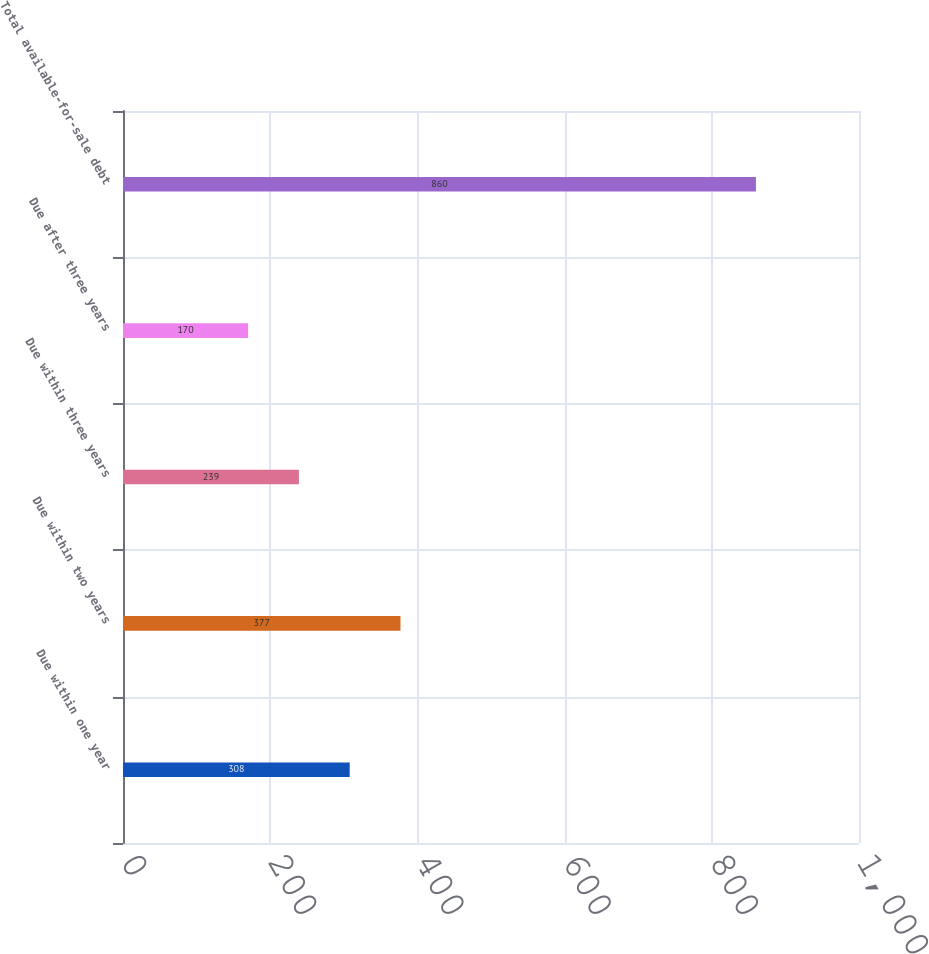Convert chart. <chart><loc_0><loc_0><loc_500><loc_500><bar_chart><fcel>Due within one year<fcel>Due within two years<fcel>Due within three years<fcel>Due after three years<fcel>Total available-for-sale debt<nl><fcel>308<fcel>377<fcel>239<fcel>170<fcel>860<nl></chart> 